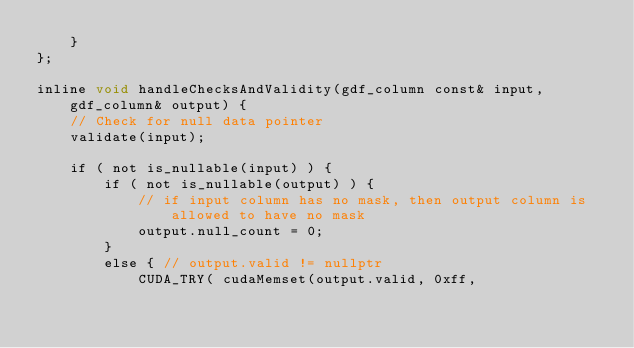<code> <loc_0><loc_0><loc_500><loc_500><_Cuda_>    }
};

inline void handleChecksAndValidity(gdf_column const& input, gdf_column& output) {
    // Check for null data pointer
    validate(input);

    if ( not is_nullable(input) ) {
        if ( not is_nullable(output) ) {
            // if input column has no mask, then output column is allowed to have no mask
            output.null_count = 0;
        }
        else { // output.valid != nullptr
            CUDA_TRY( cudaMemset(output.valid, 0xff,</code> 